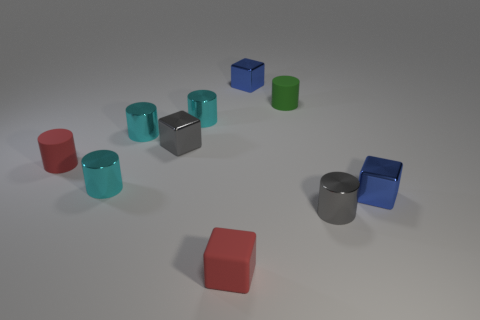Does the gray object to the right of the green object have the same shape as the green object?
Your answer should be compact. Yes. Is the number of blue metallic things that are right of the tiny gray cylinder greater than the number of big cyan shiny objects?
Make the answer very short. Yes. There is a small rubber cylinder on the left side of the gray cube; does it have the same color as the tiny matte block?
Offer a very short reply. Yes. There is a small rubber thing behind the matte cylinder that is to the left of the tiny cube behind the green matte cylinder; what color is it?
Your response must be concise. Green. How many blue metallic things have the same size as the gray metal cube?
Your answer should be compact. 2. There is a small matte object that is the same color as the small matte block; what shape is it?
Ensure brevity in your answer.  Cylinder. Are the blue thing that is in front of the small green thing and the blue thing that is left of the gray cylinder made of the same material?
Keep it short and to the point. Yes. What color is the small matte cube?
Make the answer very short. Red. How many metallic things are the same shape as the green rubber object?
Give a very brief answer. 4. There is a matte cube that is the same size as the gray metallic cylinder; what is its color?
Make the answer very short. Red. 